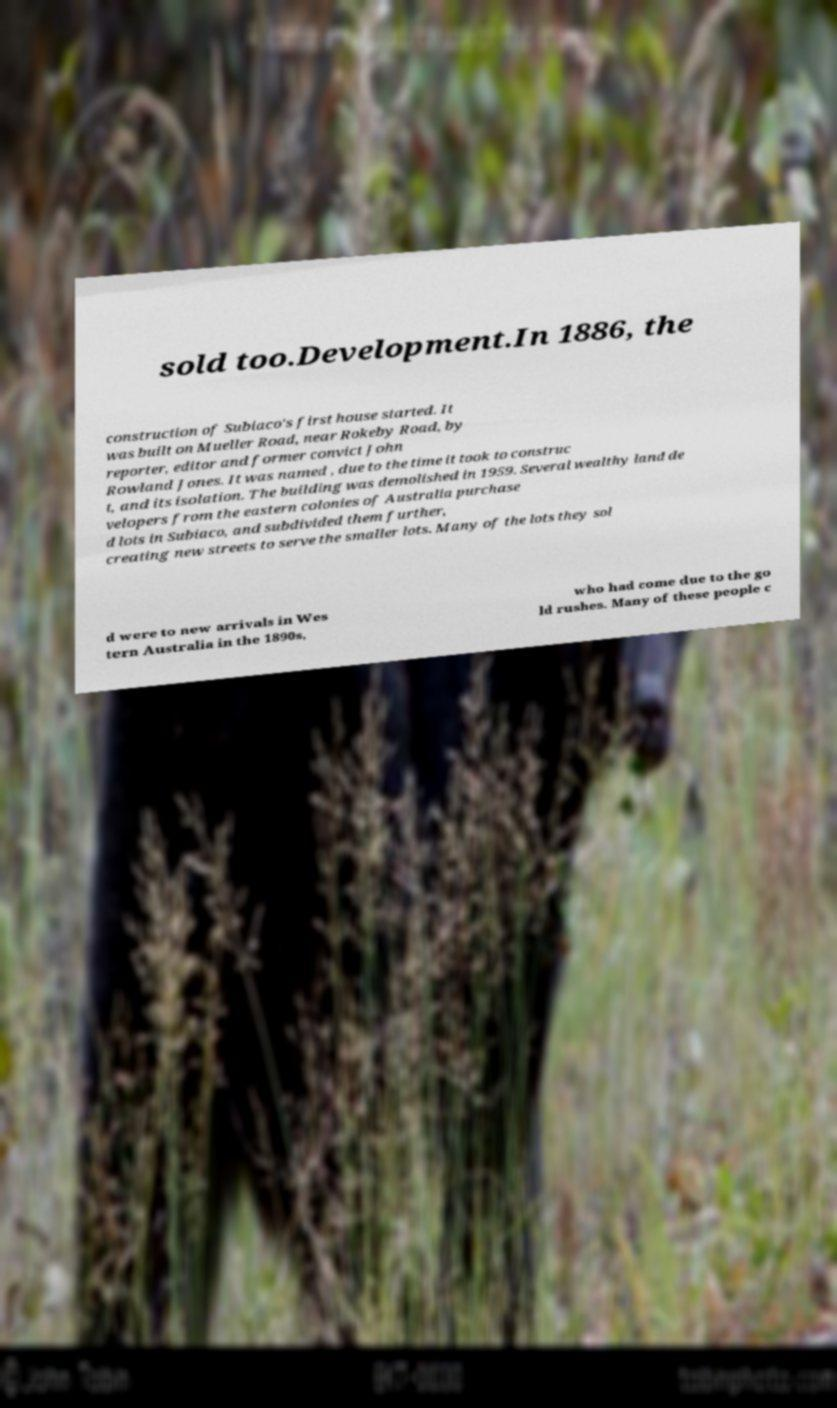Please read and relay the text visible in this image. What does it say? sold too.Development.In 1886, the construction of Subiaco's first house started. It was built on Mueller Road, near Rokeby Road, by reporter, editor and former convict John Rowland Jones. It was named , due to the time it took to construc t, and its isolation. The building was demolished in 1959. Several wealthy land de velopers from the eastern colonies of Australia purchase d lots in Subiaco, and subdivided them further, creating new streets to serve the smaller lots. Many of the lots they sol d were to new arrivals in Wes tern Australia in the 1890s, who had come due to the go ld rushes. Many of these people c 